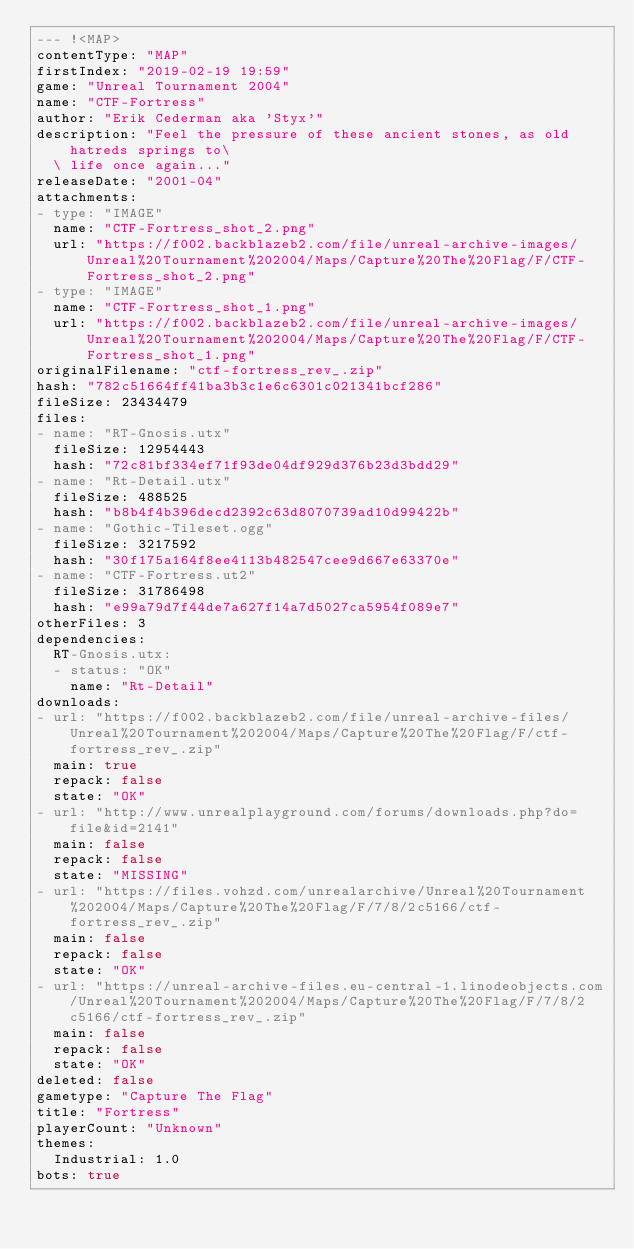Convert code to text. <code><loc_0><loc_0><loc_500><loc_500><_YAML_>--- !<MAP>
contentType: "MAP"
firstIndex: "2019-02-19 19:59"
game: "Unreal Tournament 2004"
name: "CTF-Fortress"
author: "Erik Cederman aka 'Styx'"
description: "Feel the pressure of these ancient stones, as old hatreds springs to\
  \ life once again..."
releaseDate: "2001-04"
attachments:
- type: "IMAGE"
  name: "CTF-Fortress_shot_2.png"
  url: "https://f002.backblazeb2.com/file/unreal-archive-images/Unreal%20Tournament%202004/Maps/Capture%20The%20Flag/F/CTF-Fortress_shot_2.png"
- type: "IMAGE"
  name: "CTF-Fortress_shot_1.png"
  url: "https://f002.backblazeb2.com/file/unreal-archive-images/Unreal%20Tournament%202004/Maps/Capture%20The%20Flag/F/CTF-Fortress_shot_1.png"
originalFilename: "ctf-fortress_rev_.zip"
hash: "782c51664ff41ba3b3c1e6c6301c021341bcf286"
fileSize: 23434479
files:
- name: "RT-Gnosis.utx"
  fileSize: 12954443
  hash: "72c81bf334ef71f93de04df929d376b23d3bdd29"
- name: "Rt-Detail.utx"
  fileSize: 488525
  hash: "b8b4f4b396decd2392c63d8070739ad10d99422b"
- name: "Gothic-Tileset.ogg"
  fileSize: 3217592
  hash: "30f175a164f8ee4113b482547cee9d667e63370e"
- name: "CTF-Fortress.ut2"
  fileSize: 31786498
  hash: "e99a79d7f44de7a627f14a7d5027ca5954f089e7"
otherFiles: 3
dependencies:
  RT-Gnosis.utx:
  - status: "OK"
    name: "Rt-Detail"
downloads:
- url: "https://f002.backblazeb2.com/file/unreal-archive-files/Unreal%20Tournament%202004/Maps/Capture%20The%20Flag/F/ctf-fortress_rev_.zip"
  main: true
  repack: false
  state: "OK"
- url: "http://www.unrealplayground.com/forums/downloads.php?do=file&id=2141"
  main: false
  repack: false
  state: "MISSING"
- url: "https://files.vohzd.com/unrealarchive/Unreal%20Tournament%202004/Maps/Capture%20The%20Flag/F/7/8/2c5166/ctf-fortress_rev_.zip"
  main: false
  repack: false
  state: "OK"
- url: "https://unreal-archive-files.eu-central-1.linodeobjects.com/Unreal%20Tournament%202004/Maps/Capture%20The%20Flag/F/7/8/2c5166/ctf-fortress_rev_.zip"
  main: false
  repack: false
  state: "OK"
deleted: false
gametype: "Capture The Flag"
title: "Fortress"
playerCount: "Unknown"
themes:
  Industrial: 1.0
bots: true
</code> 